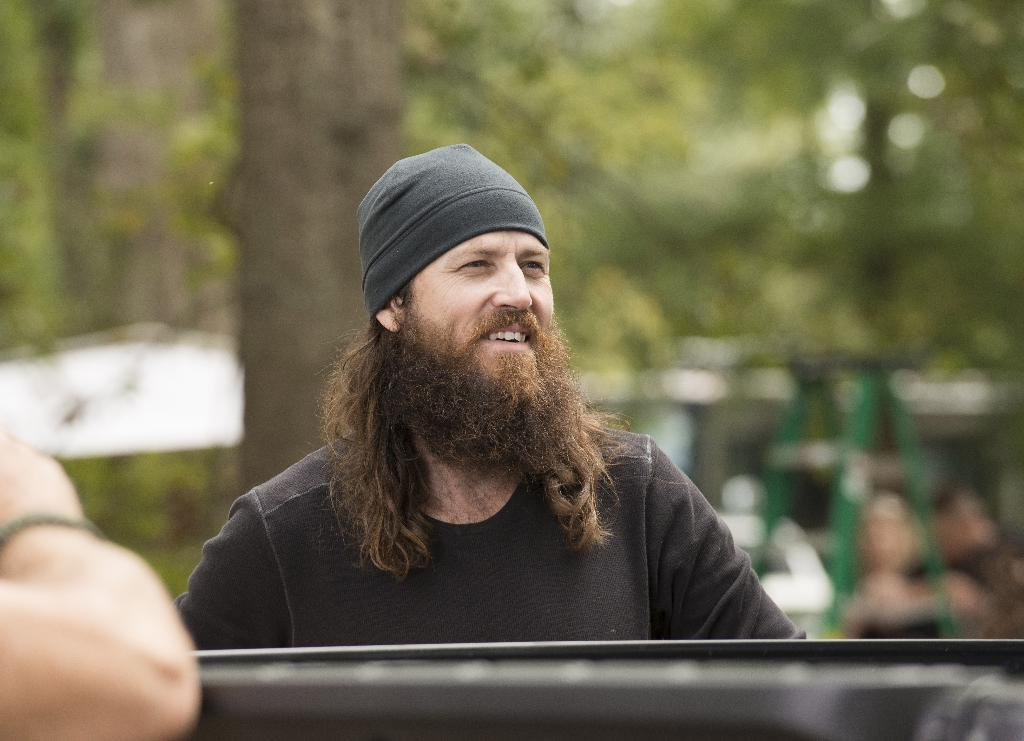What is the main subject of the image? There is a man in the image. What is the man's facial expression? The man is smiling. What color is the t-shirt the man is wearing? The man is wearing a black t-shirt. What type of headwear is the man wearing? The man is wearing a cap. What can be seen in the background of the image? There are trees visible in the background of the image. How many patches can be seen on the man's thumb in the image? There is no mention of patches or the man's thumb in the image, so it cannot be determined. 